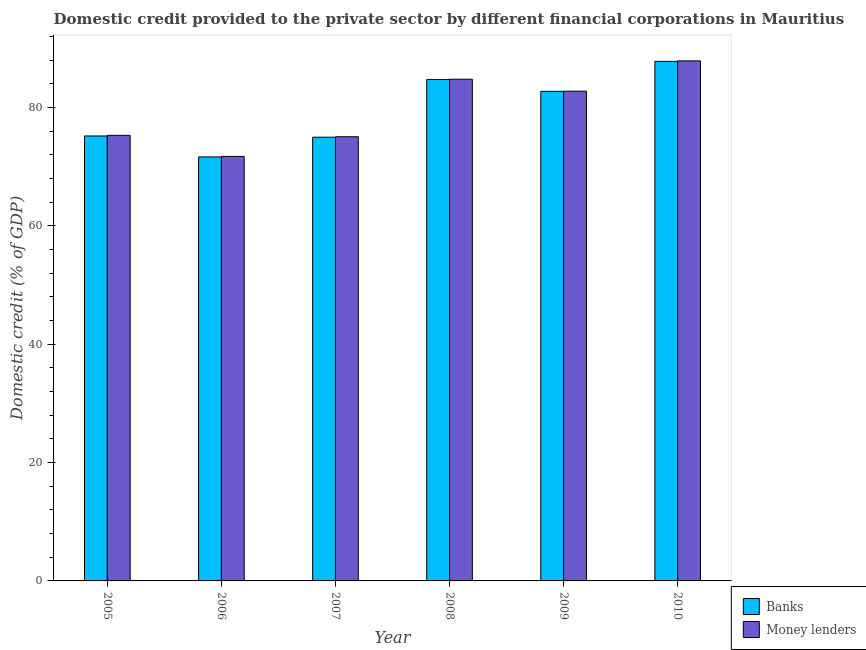How many different coloured bars are there?
Give a very brief answer. 2. Are the number of bars on each tick of the X-axis equal?
Provide a short and direct response. Yes. How many bars are there on the 3rd tick from the left?
Provide a short and direct response. 2. How many bars are there on the 1st tick from the right?
Ensure brevity in your answer.  2. In how many cases, is the number of bars for a given year not equal to the number of legend labels?
Offer a very short reply. 0. What is the domestic credit provided by banks in 2009?
Provide a short and direct response. 82.71. Across all years, what is the maximum domestic credit provided by banks?
Give a very brief answer. 87.78. Across all years, what is the minimum domestic credit provided by money lenders?
Provide a short and direct response. 71.72. In which year was the domestic credit provided by money lenders minimum?
Offer a very short reply. 2006. What is the total domestic credit provided by banks in the graph?
Your answer should be compact. 477. What is the difference between the domestic credit provided by money lenders in 2007 and that in 2010?
Give a very brief answer. -12.82. What is the difference between the domestic credit provided by banks in 2009 and the domestic credit provided by money lenders in 2007?
Provide a short and direct response. 7.74. What is the average domestic credit provided by money lenders per year?
Give a very brief answer. 79.57. In the year 2009, what is the difference between the domestic credit provided by money lenders and domestic credit provided by banks?
Keep it short and to the point. 0. What is the ratio of the domestic credit provided by money lenders in 2005 to that in 2007?
Ensure brevity in your answer.  1. What is the difference between the highest and the second highest domestic credit provided by money lenders?
Provide a succinct answer. 3.1. What is the difference between the highest and the lowest domestic credit provided by banks?
Offer a terse response. 16.15. In how many years, is the domestic credit provided by banks greater than the average domestic credit provided by banks taken over all years?
Your answer should be compact. 3. What does the 1st bar from the left in 2010 represents?
Give a very brief answer. Banks. What does the 1st bar from the right in 2009 represents?
Your response must be concise. Money lenders. How many bars are there?
Ensure brevity in your answer.  12. Are all the bars in the graph horizontal?
Keep it short and to the point. No. What is the difference between two consecutive major ticks on the Y-axis?
Ensure brevity in your answer.  20. Are the values on the major ticks of Y-axis written in scientific E-notation?
Your answer should be very brief. No. Does the graph contain any zero values?
Offer a terse response. No. Where does the legend appear in the graph?
Provide a succinct answer. Bottom right. How many legend labels are there?
Give a very brief answer. 2. How are the legend labels stacked?
Your answer should be compact. Vertical. What is the title of the graph?
Offer a terse response. Domestic credit provided to the private sector by different financial corporations in Mauritius. Does "Borrowers" appear as one of the legend labels in the graph?
Make the answer very short. No. What is the label or title of the Y-axis?
Your response must be concise. Domestic credit (% of GDP). What is the Domestic credit (% of GDP) in Banks in 2005?
Your answer should be very brief. 75.18. What is the Domestic credit (% of GDP) in Money lenders in 2005?
Your response must be concise. 75.28. What is the Domestic credit (% of GDP) of Banks in 2006?
Offer a terse response. 71.63. What is the Domestic credit (% of GDP) of Money lenders in 2006?
Provide a succinct answer. 71.72. What is the Domestic credit (% of GDP) of Banks in 2007?
Offer a terse response. 74.97. What is the Domestic credit (% of GDP) of Money lenders in 2007?
Your response must be concise. 75.04. What is the Domestic credit (% of GDP) of Banks in 2008?
Your response must be concise. 84.72. What is the Domestic credit (% of GDP) in Money lenders in 2008?
Your answer should be very brief. 84.76. What is the Domestic credit (% of GDP) in Banks in 2009?
Ensure brevity in your answer.  82.71. What is the Domestic credit (% of GDP) of Money lenders in 2009?
Keep it short and to the point. 82.74. What is the Domestic credit (% of GDP) of Banks in 2010?
Provide a short and direct response. 87.78. What is the Domestic credit (% of GDP) of Money lenders in 2010?
Keep it short and to the point. 87.86. Across all years, what is the maximum Domestic credit (% of GDP) in Banks?
Give a very brief answer. 87.78. Across all years, what is the maximum Domestic credit (% of GDP) in Money lenders?
Provide a short and direct response. 87.86. Across all years, what is the minimum Domestic credit (% of GDP) of Banks?
Make the answer very short. 71.63. Across all years, what is the minimum Domestic credit (% of GDP) of Money lenders?
Your answer should be very brief. 71.72. What is the total Domestic credit (% of GDP) of Banks in the graph?
Make the answer very short. 477. What is the total Domestic credit (% of GDP) in Money lenders in the graph?
Your response must be concise. 477.41. What is the difference between the Domestic credit (% of GDP) of Banks in 2005 and that in 2006?
Provide a succinct answer. 3.55. What is the difference between the Domestic credit (% of GDP) of Money lenders in 2005 and that in 2006?
Offer a very short reply. 3.56. What is the difference between the Domestic credit (% of GDP) in Banks in 2005 and that in 2007?
Give a very brief answer. 0.21. What is the difference between the Domestic credit (% of GDP) of Money lenders in 2005 and that in 2007?
Your answer should be compact. 0.23. What is the difference between the Domestic credit (% of GDP) in Banks in 2005 and that in 2008?
Provide a succinct answer. -9.55. What is the difference between the Domestic credit (% of GDP) of Money lenders in 2005 and that in 2008?
Ensure brevity in your answer.  -9.49. What is the difference between the Domestic credit (% of GDP) in Banks in 2005 and that in 2009?
Make the answer very short. -7.53. What is the difference between the Domestic credit (% of GDP) in Money lenders in 2005 and that in 2009?
Make the answer very short. -7.47. What is the difference between the Domestic credit (% of GDP) in Banks in 2005 and that in 2010?
Make the answer very short. -12.6. What is the difference between the Domestic credit (% of GDP) in Money lenders in 2005 and that in 2010?
Your response must be concise. -12.59. What is the difference between the Domestic credit (% of GDP) of Banks in 2006 and that in 2007?
Offer a very short reply. -3.34. What is the difference between the Domestic credit (% of GDP) in Money lenders in 2006 and that in 2007?
Your answer should be very brief. -3.32. What is the difference between the Domestic credit (% of GDP) in Banks in 2006 and that in 2008?
Make the answer very short. -13.09. What is the difference between the Domestic credit (% of GDP) in Money lenders in 2006 and that in 2008?
Keep it short and to the point. -13.04. What is the difference between the Domestic credit (% of GDP) of Banks in 2006 and that in 2009?
Your answer should be very brief. -11.08. What is the difference between the Domestic credit (% of GDP) of Money lenders in 2006 and that in 2009?
Offer a very short reply. -11.02. What is the difference between the Domestic credit (% of GDP) of Banks in 2006 and that in 2010?
Make the answer very short. -16.15. What is the difference between the Domestic credit (% of GDP) in Money lenders in 2006 and that in 2010?
Make the answer very short. -16.14. What is the difference between the Domestic credit (% of GDP) of Banks in 2007 and that in 2008?
Provide a short and direct response. -9.76. What is the difference between the Domestic credit (% of GDP) in Money lenders in 2007 and that in 2008?
Provide a succinct answer. -9.72. What is the difference between the Domestic credit (% of GDP) in Banks in 2007 and that in 2009?
Your answer should be compact. -7.74. What is the difference between the Domestic credit (% of GDP) of Money lenders in 2007 and that in 2009?
Provide a short and direct response. -7.7. What is the difference between the Domestic credit (% of GDP) of Banks in 2007 and that in 2010?
Offer a terse response. -12.81. What is the difference between the Domestic credit (% of GDP) of Money lenders in 2007 and that in 2010?
Give a very brief answer. -12.82. What is the difference between the Domestic credit (% of GDP) in Banks in 2008 and that in 2009?
Offer a very short reply. 2.01. What is the difference between the Domestic credit (% of GDP) of Money lenders in 2008 and that in 2009?
Your answer should be very brief. 2.02. What is the difference between the Domestic credit (% of GDP) in Banks in 2008 and that in 2010?
Your answer should be compact. -3.06. What is the difference between the Domestic credit (% of GDP) of Money lenders in 2008 and that in 2010?
Keep it short and to the point. -3.1. What is the difference between the Domestic credit (% of GDP) of Banks in 2009 and that in 2010?
Keep it short and to the point. -5.07. What is the difference between the Domestic credit (% of GDP) in Money lenders in 2009 and that in 2010?
Offer a very short reply. -5.12. What is the difference between the Domestic credit (% of GDP) of Banks in 2005 and the Domestic credit (% of GDP) of Money lenders in 2006?
Give a very brief answer. 3.46. What is the difference between the Domestic credit (% of GDP) in Banks in 2005 and the Domestic credit (% of GDP) in Money lenders in 2007?
Offer a very short reply. 0.13. What is the difference between the Domestic credit (% of GDP) in Banks in 2005 and the Domestic credit (% of GDP) in Money lenders in 2008?
Your response must be concise. -9.58. What is the difference between the Domestic credit (% of GDP) in Banks in 2005 and the Domestic credit (% of GDP) in Money lenders in 2009?
Your response must be concise. -7.57. What is the difference between the Domestic credit (% of GDP) in Banks in 2005 and the Domestic credit (% of GDP) in Money lenders in 2010?
Make the answer very short. -12.68. What is the difference between the Domestic credit (% of GDP) of Banks in 2006 and the Domestic credit (% of GDP) of Money lenders in 2007?
Provide a succinct answer. -3.41. What is the difference between the Domestic credit (% of GDP) of Banks in 2006 and the Domestic credit (% of GDP) of Money lenders in 2008?
Your response must be concise. -13.13. What is the difference between the Domestic credit (% of GDP) in Banks in 2006 and the Domestic credit (% of GDP) in Money lenders in 2009?
Keep it short and to the point. -11.11. What is the difference between the Domestic credit (% of GDP) in Banks in 2006 and the Domestic credit (% of GDP) in Money lenders in 2010?
Give a very brief answer. -16.23. What is the difference between the Domestic credit (% of GDP) in Banks in 2007 and the Domestic credit (% of GDP) in Money lenders in 2008?
Ensure brevity in your answer.  -9.79. What is the difference between the Domestic credit (% of GDP) in Banks in 2007 and the Domestic credit (% of GDP) in Money lenders in 2009?
Your answer should be very brief. -7.78. What is the difference between the Domestic credit (% of GDP) of Banks in 2007 and the Domestic credit (% of GDP) of Money lenders in 2010?
Offer a terse response. -12.89. What is the difference between the Domestic credit (% of GDP) of Banks in 2008 and the Domestic credit (% of GDP) of Money lenders in 2009?
Ensure brevity in your answer.  1.98. What is the difference between the Domestic credit (% of GDP) of Banks in 2008 and the Domestic credit (% of GDP) of Money lenders in 2010?
Your answer should be very brief. -3.14. What is the difference between the Domestic credit (% of GDP) of Banks in 2009 and the Domestic credit (% of GDP) of Money lenders in 2010?
Offer a very short reply. -5.15. What is the average Domestic credit (% of GDP) in Banks per year?
Ensure brevity in your answer.  79.5. What is the average Domestic credit (% of GDP) in Money lenders per year?
Provide a succinct answer. 79.57. In the year 2005, what is the difference between the Domestic credit (% of GDP) in Banks and Domestic credit (% of GDP) in Money lenders?
Provide a succinct answer. -0.1. In the year 2006, what is the difference between the Domestic credit (% of GDP) in Banks and Domestic credit (% of GDP) in Money lenders?
Offer a terse response. -0.09. In the year 2007, what is the difference between the Domestic credit (% of GDP) of Banks and Domestic credit (% of GDP) of Money lenders?
Keep it short and to the point. -0.08. In the year 2008, what is the difference between the Domestic credit (% of GDP) in Banks and Domestic credit (% of GDP) in Money lenders?
Your answer should be compact. -0.04. In the year 2009, what is the difference between the Domestic credit (% of GDP) of Banks and Domestic credit (% of GDP) of Money lenders?
Ensure brevity in your answer.  -0.03. In the year 2010, what is the difference between the Domestic credit (% of GDP) in Banks and Domestic credit (% of GDP) in Money lenders?
Give a very brief answer. -0.08. What is the ratio of the Domestic credit (% of GDP) of Banks in 2005 to that in 2006?
Provide a short and direct response. 1.05. What is the ratio of the Domestic credit (% of GDP) in Money lenders in 2005 to that in 2006?
Keep it short and to the point. 1.05. What is the ratio of the Domestic credit (% of GDP) of Banks in 2005 to that in 2008?
Your answer should be compact. 0.89. What is the ratio of the Domestic credit (% of GDP) in Money lenders in 2005 to that in 2008?
Your answer should be very brief. 0.89. What is the ratio of the Domestic credit (% of GDP) of Banks in 2005 to that in 2009?
Make the answer very short. 0.91. What is the ratio of the Domestic credit (% of GDP) in Money lenders in 2005 to that in 2009?
Offer a terse response. 0.91. What is the ratio of the Domestic credit (% of GDP) of Banks in 2005 to that in 2010?
Provide a succinct answer. 0.86. What is the ratio of the Domestic credit (% of GDP) in Money lenders in 2005 to that in 2010?
Keep it short and to the point. 0.86. What is the ratio of the Domestic credit (% of GDP) in Banks in 2006 to that in 2007?
Make the answer very short. 0.96. What is the ratio of the Domestic credit (% of GDP) of Money lenders in 2006 to that in 2007?
Ensure brevity in your answer.  0.96. What is the ratio of the Domestic credit (% of GDP) in Banks in 2006 to that in 2008?
Your response must be concise. 0.85. What is the ratio of the Domestic credit (% of GDP) of Money lenders in 2006 to that in 2008?
Ensure brevity in your answer.  0.85. What is the ratio of the Domestic credit (% of GDP) of Banks in 2006 to that in 2009?
Your answer should be very brief. 0.87. What is the ratio of the Domestic credit (% of GDP) of Money lenders in 2006 to that in 2009?
Your response must be concise. 0.87. What is the ratio of the Domestic credit (% of GDP) of Banks in 2006 to that in 2010?
Keep it short and to the point. 0.82. What is the ratio of the Domestic credit (% of GDP) of Money lenders in 2006 to that in 2010?
Your response must be concise. 0.82. What is the ratio of the Domestic credit (% of GDP) of Banks in 2007 to that in 2008?
Offer a terse response. 0.88. What is the ratio of the Domestic credit (% of GDP) of Money lenders in 2007 to that in 2008?
Make the answer very short. 0.89. What is the ratio of the Domestic credit (% of GDP) of Banks in 2007 to that in 2009?
Provide a succinct answer. 0.91. What is the ratio of the Domestic credit (% of GDP) of Money lenders in 2007 to that in 2009?
Offer a very short reply. 0.91. What is the ratio of the Domestic credit (% of GDP) of Banks in 2007 to that in 2010?
Offer a terse response. 0.85. What is the ratio of the Domestic credit (% of GDP) of Money lenders in 2007 to that in 2010?
Provide a succinct answer. 0.85. What is the ratio of the Domestic credit (% of GDP) in Banks in 2008 to that in 2009?
Ensure brevity in your answer.  1.02. What is the ratio of the Domestic credit (% of GDP) in Money lenders in 2008 to that in 2009?
Offer a very short reply. 1.02. What is the ratio of the Domestic credit (% of GDP) of Banks in 2008 to that in 2010?
Offer a terse response. 0.97. What is the ratio of the Domestic credit (% of GDP) of Money lenders in 2008 to that in 2010?
Provide a short and direct response. 0.96. What is the ratio of the Domestic credit (% of GDP) of Banks in 2009 to that in 2010?
Make the answer very short. 0.94. What is the ratio of the Domestic credit (% of GDP) in Money lenders in 2009 to that in 2010?
Your answer should be compact. 0.94. What is the difference between the highest and the second highest Domestic credit (% of GDP) of Banks?
Make the answer very short. 3.06. What is the difference between the highest and the second highest Domestic credit (% of GDP) in Money lenders?
Keep it short and to the point. 3.1. What is the difference between the highest and the lowest Domestic credit (% of GDP) in Banks?
Give a very brief answer. 16.15. What is the difference between the highest and the lowest Domestic credit (% of GDP) in Money lenders?
Provide a short and direct response. 16.14. 